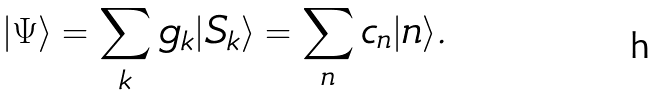Convert formula to latex. <formula><loc_0><loc_0><loc_500><loc_500>| \Psi \rangle = \sum _ { k } g _ { k } | S _ { k } \rangle = \sum _ { n } c _ { n } | n \rangle .</formula> 